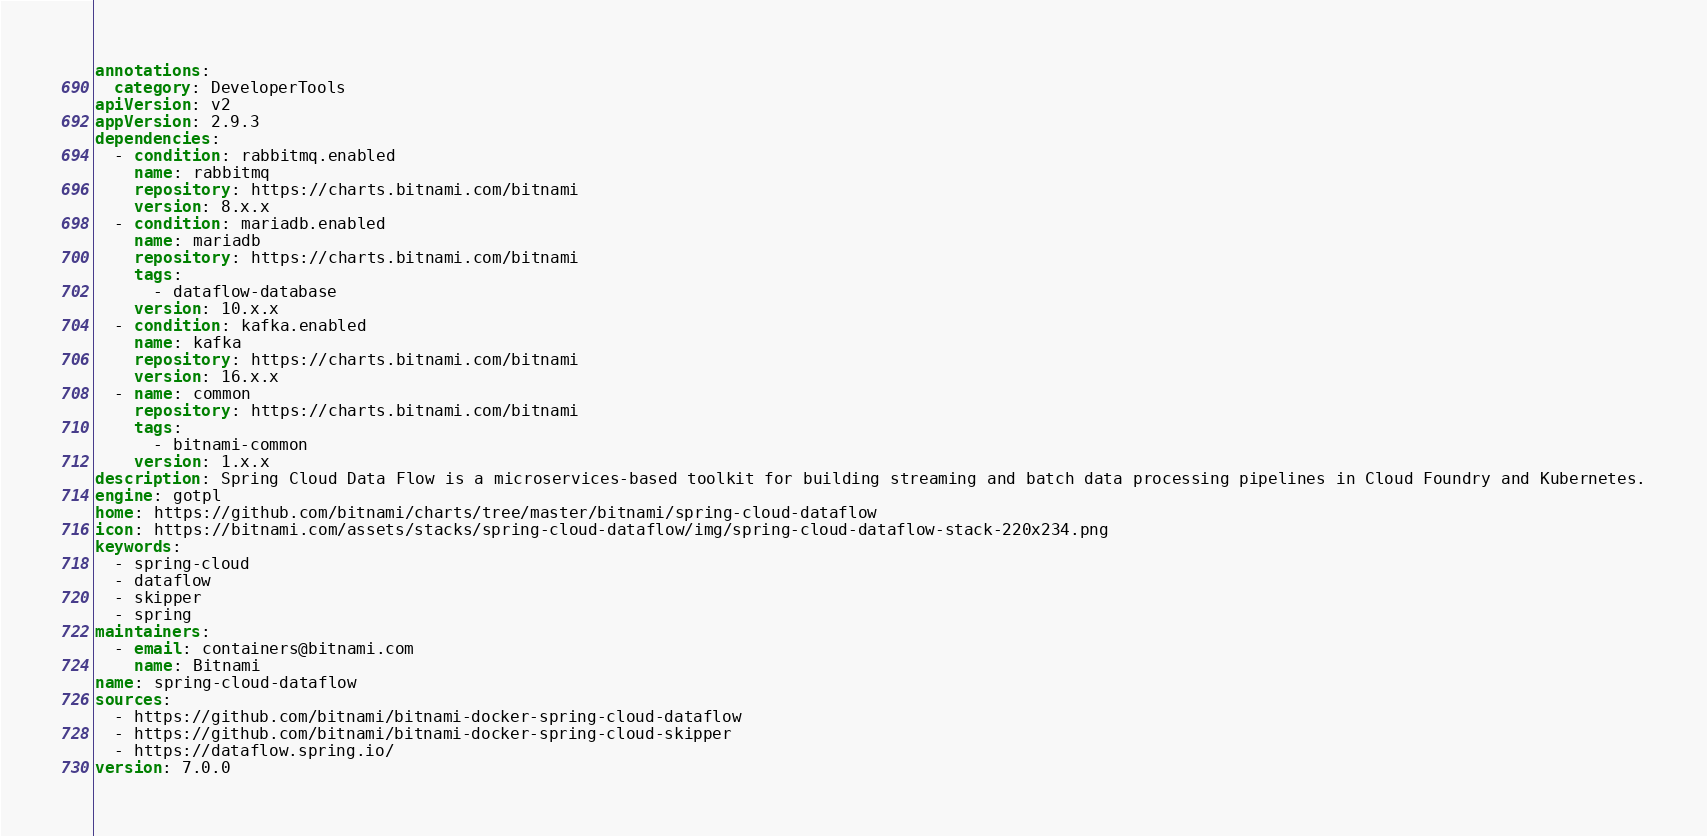Convert code to text. <code><loc_0><loc_0><loc_500><loc_500><_YAML_>annotations:
  category: DeveloperTools
apiVersion: v2
appVersion: 2.9.3
dependencies:
  - condition: rabbitmq.enabled
    name: rabbitmq
    repository: https://charts.bitnami.com/bitnami
    version: 8.x.x
  - condition: mariadb.enabled
    name: mariadb
    repository: https://charts.bitnami.com/bitnami
    tags:
      - dataflow-database
    version: 10.x.x
  - condition: kafka.enabled
    name: kafka
    repository: https://charts.bitnami.com/bitnami
    version: 16.x.x
  - name: common
    repository: https://charts.bitnami.com/bitnami
    tags:
      - bitnami-common
    version: 1.x.x
description: Spring Cloud Data Flow is a microservices-based toolkit for building streaming and batch data processing pipelines in Cloud Foundry and Kubernetes.
engine: gotpl
home: https://github.com/bitnami/charts/tree/master/bitnami/spring-cloud-dataflow
icon: https://bitnami.com/assets/stacks/spring-cloud-dataflow/img/spring-cloud-dataflow-stack-220x234.png
keywords:
  - spring-cloud
  - dataflow
  - skipper
  - spring
maintainers:
  - email: containers@bitnami.com
    name: Bitnami
name: spring-cloud-dataflow
sources:
  - https://github.com/bitnami/bitnami-docker-spring-cloud-dataflow
  - https://github.com/bitnami/bitnami-docker-spring-cloud-skipper
  - https://dataflow.spring.io/
version: 7.0.0
</code> 